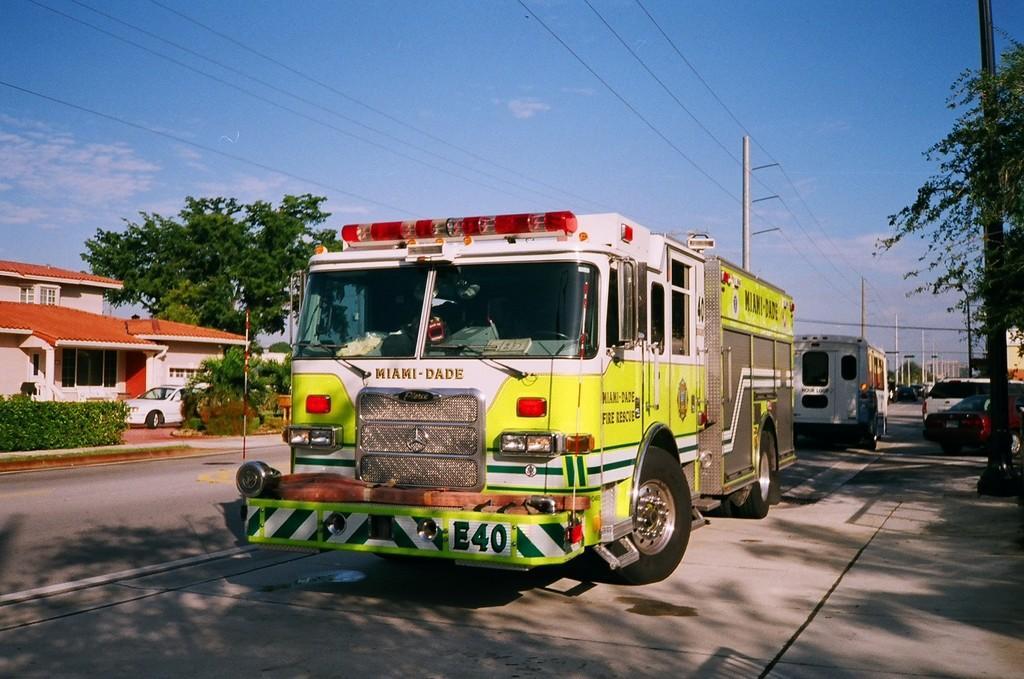Describe this image in one or two sentences. Here we can see vehicles on the road. In the background there are trees,poles,vehicles,buildings,windows,electric poles,wires and clouds in the sky. 